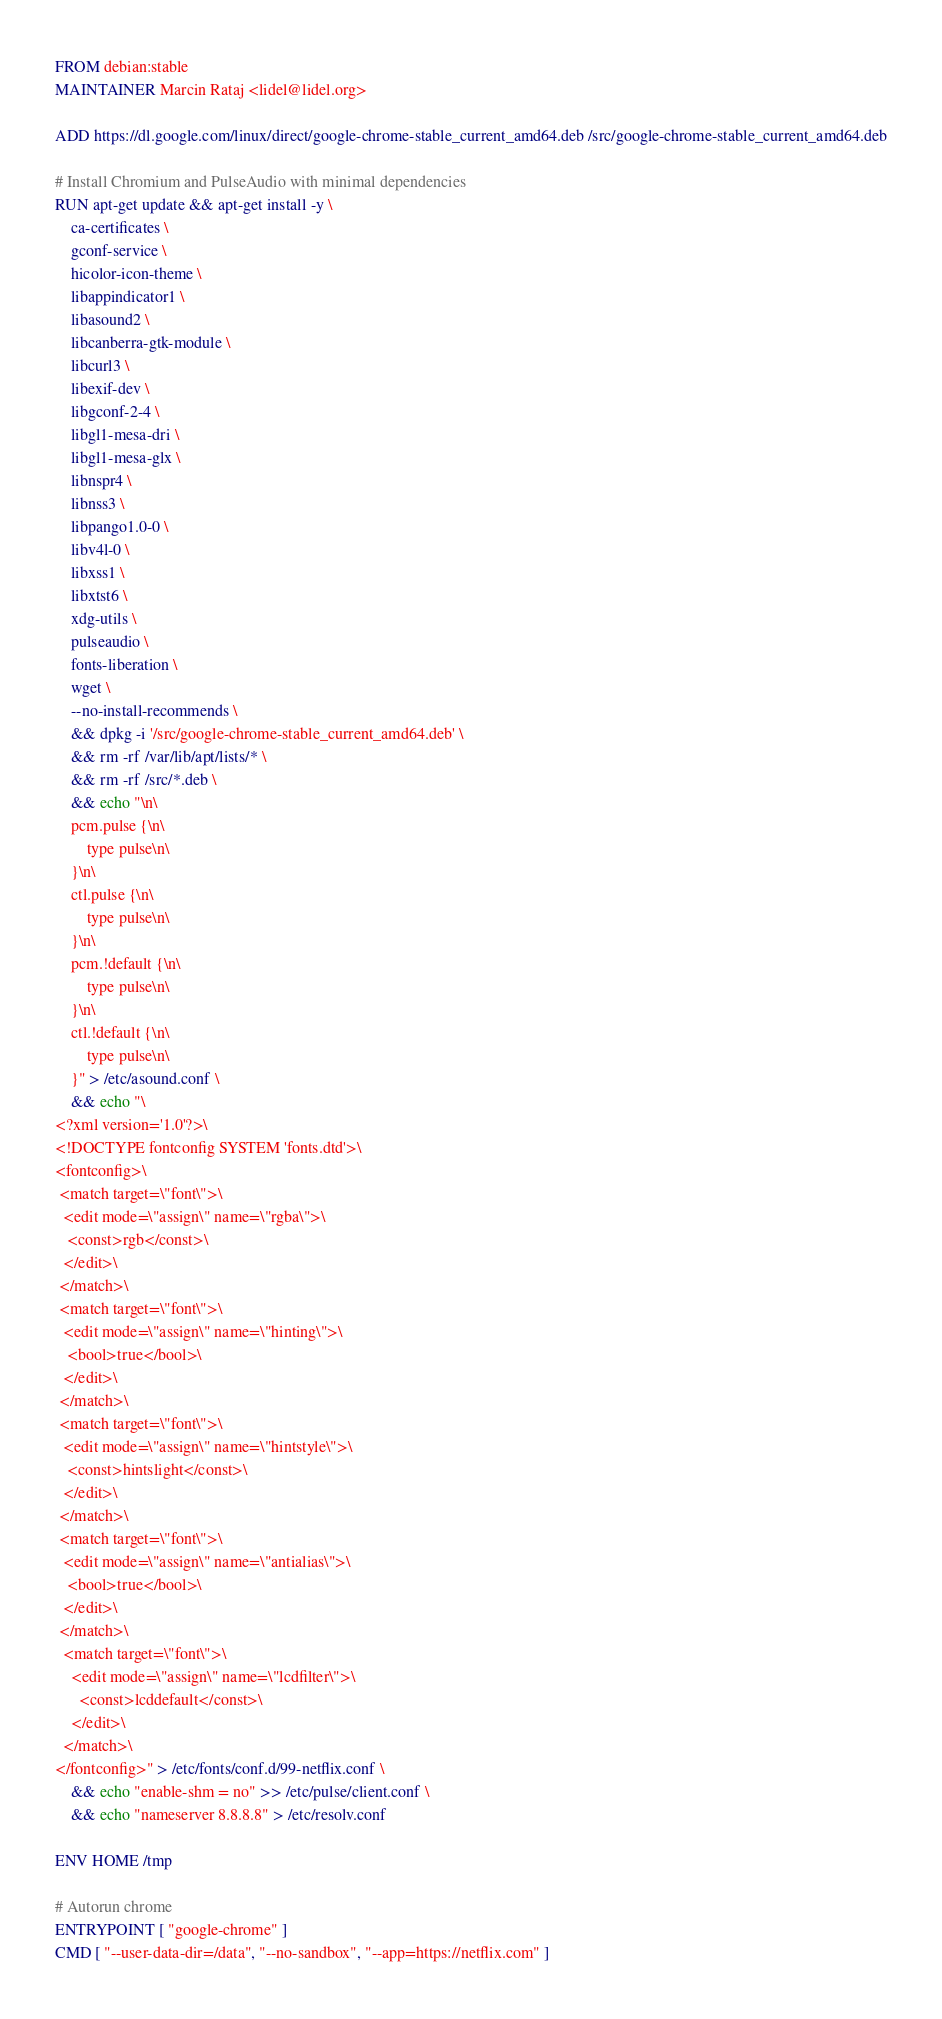<code> <loc_0><loc_0><loc_500><loc_500><_Dockerfile_>FROM debian:stable
MAINTAINER Marcin Rataj <lidel@lidel.org>

ADD https://dl.google.com/linux/direct/google-chrome-stable_current_amd64.deb /src/google-chrome-stable_current_amd64.deb

# Install Chromium and PulseAudio with minimal dependencies
RUN apt-get update && apt-get install -y \
    ca-certificates \
    gconf-service \
    hicolor-icon-theme \
    libappindicator1 \
    libasound2 \
    libcanberra-gtk-module \
    libcurl3 \
    libexif-dev \
    libgconf-2-4 \
    libgl1-mesa-dri \
    libgl1-mesa-glx \
    libnspr4 \
    libnss3 \
    libpango1.0-0 \
    libv4l-0 \
    libxss1 \
    libxtst6 \
    xdg-utils \
    pulseaudio \
    fonts-liberation \
    wget \
    --no-install-recommends \
    && dpkg -i '/src/google-chrome-stable_current_amd64.deb' \
    && rm -rf /var/lib/apt/lists/* \
    && rm -rf /src/*.deb \
    && echo "\n\
    pcm.pulse {\n\
        type pulse\n\
    }\n\
    ctl.pulse {\n\
        type pulse\n\
    }\n\
    pcm.!default {\n\
        type pulse\n\
    }\n\
    ctl.!default {\n\
        type pulse\n\
    }" > /etc/asound.conf \
    && echo "\
<?xml version='1.0'?>\
<!DOCTYPE fontconfig SYSTEM 'fonts.dtd'>\
<fontconfig>\
 <match target=\"font\">\
  <edit mode=\"assign\" name=\"rgba\">\
   <const>rgb</const>\
  </edit>\
 </match>\
 <match target=\"font\">\
  <edit mode=\"assign\" name=\"hinting\">\
   <bool>true</bool>\
  </edit>\
 </match>\
 <match target=\"font\">\
  <edit mode=\"assign\" name=\"hintstyle\">\
   <const>hintslight</const>\
  </edit>\
 </match>\
 <match target=\"font\">\
  <edit mode=\"assign\" name=\"antialias\">\
   <bool>true</bool>\
  </edit>\
 </match>\
  <match target=\"font\">\
    <edit mode=\"assign\" name=\"lcdfilter\">\
      <const>lcddefault</const>\
    </edit>\
  </match>\
</fontconfig>" > /etc/fonts/conf.d/99-netflix.conf \
    && echo "enable-shm = no" >> /etc/pulse/client.conf \
    && echo "nameserver 8.8.8.8" > /etc/resolv.conf

ENV HOME /tmp

# Autorun chrome
ENTRYPOINT [ "google-chrome" ]
CMD [ "--user-data-dir=/data", "--no-sandbox", "--app=https://netflix.com" ]
</code> 